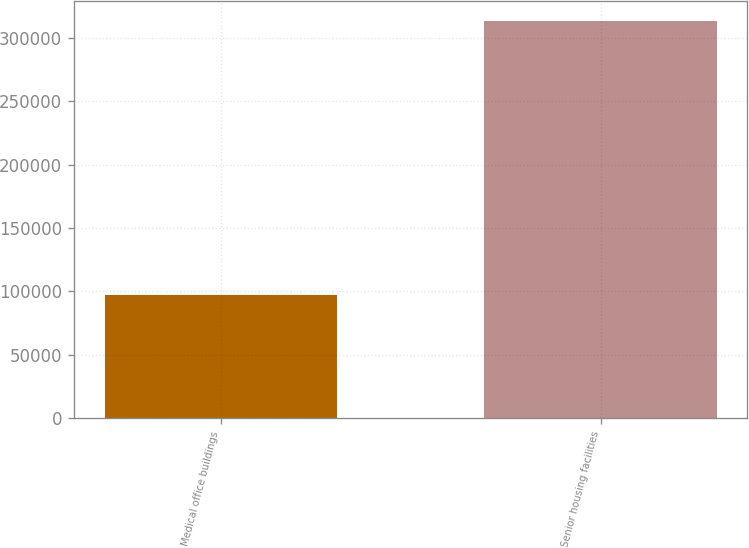Convert chart to OTSL. <chart><loc_0><loc_0><loc_500><loc_500><bar_chart><fcel>Medical office buildings<fcel>Senior housing facilities<nl><fcel>96863<fcel>313744<nl></chart> 